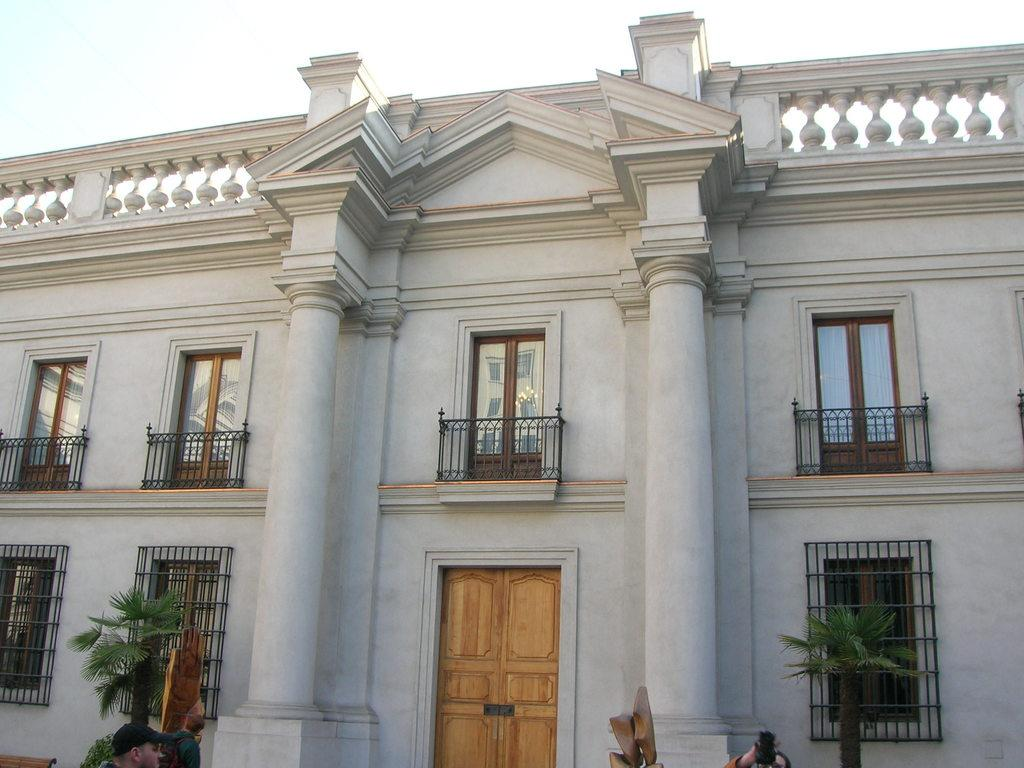Who or what can be seen in the image? There are people in the image. What type of structure is present in the image? There is a building with windows and a door in the image. What other elements are visible in the image? There are plants in the image. What can be seen in the distance in the image? The sky is visible in the background of the image. What type of paint is being used by the people in the image? There is no paint or painting activity depicted in the image. Can you tell me how many berries are on the plants in the image? There are no berries mentioned or visible in the image; only plants are present. 